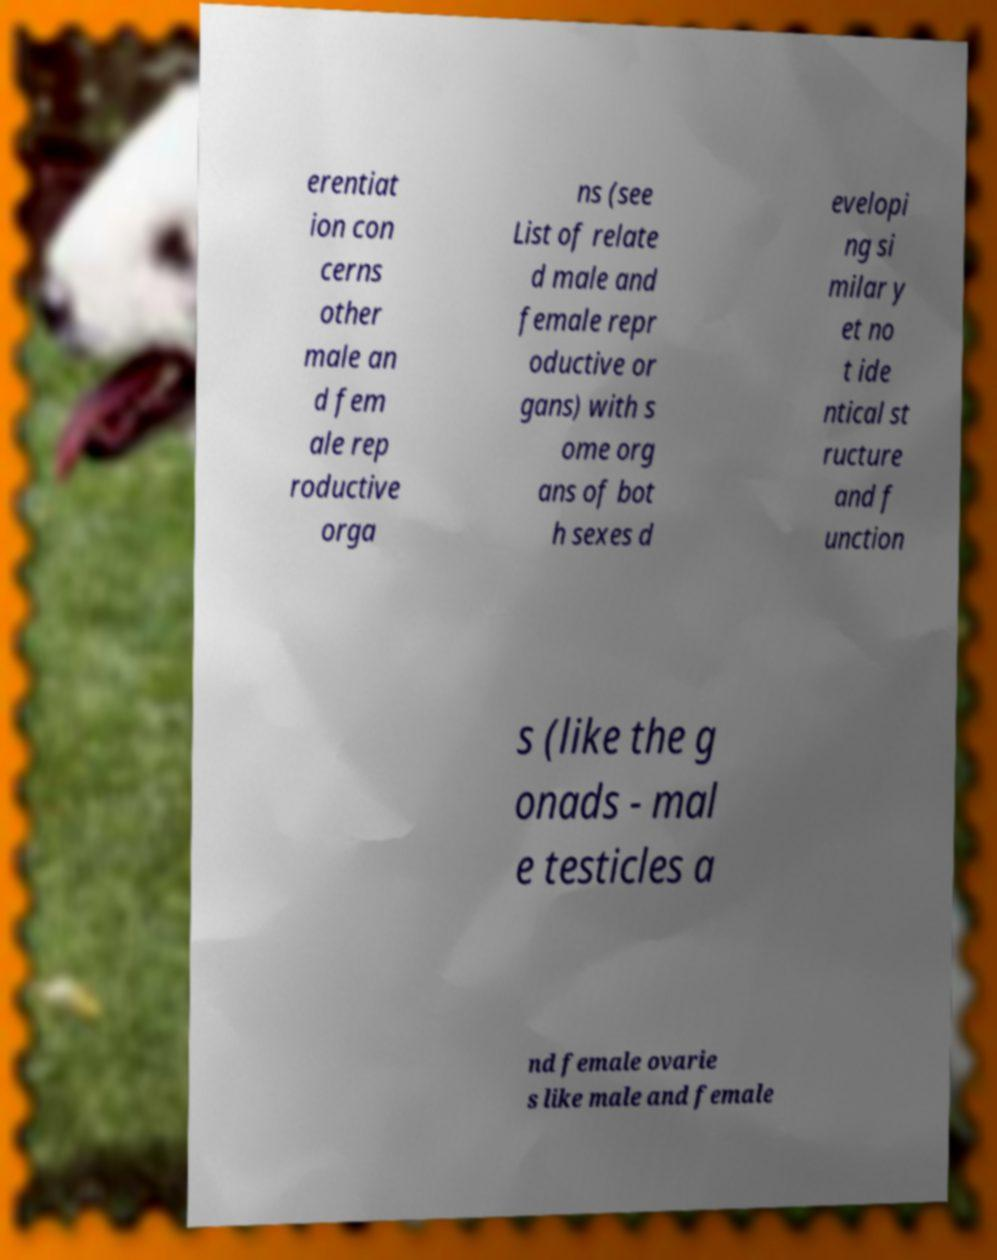Can you accurately transcribe the text from the provided image for me? erentiat ion con cerns other male an d fem ale rep roductive orga ns (see List of relate d male and female repr oductive or gans) with s ome org ans of bot h sexes d evelopi ng si milar y et no t ide ntical st ructure and f unction s (like the g onads - mal e testicles a nd female ovarie s like male and female 